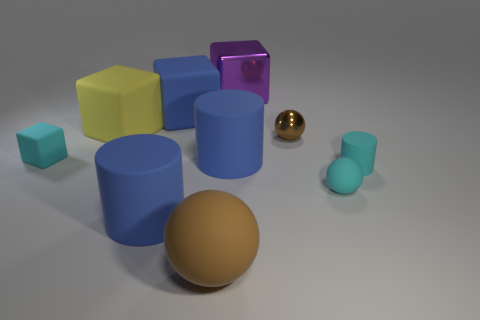What shape is the big purple object?
Offer a terse response. Cube. What color is the rubber cylinder that is both on the right side of the blue block and on the left side of the small matte cylinder?
Keep it short and to the point. Blue. What material is the purple cube?
Your answer should be very brief. Metal. The purple thing that is behind the blue cube has what shape?
Your answer should be compact. Cube. There is a rubber ball that is the same size as the purple metallic object; what color is it?
Provide a succinct answer. Brown. Is the blue object behind the cyan cube made of the same material as the small cube?
Offer a terse response. Yes. There is a cyan object that is both behind the tiny cyan rubber ball and right of the yellow matte object; what size is it?
Offer a terse response. Small. What size is the brown object that is to the right of the big brown sphere?
Offer a terse response. Small. There is a big matte thing that is the same color as the tiny shiny thing; what is its shape?
Provide a short and direct response. Sphere. There is a small cyan object that is left of the ball behind the small matte object left of the yellow cube; what shape is it?
Provide a short and direct response. Cube. 